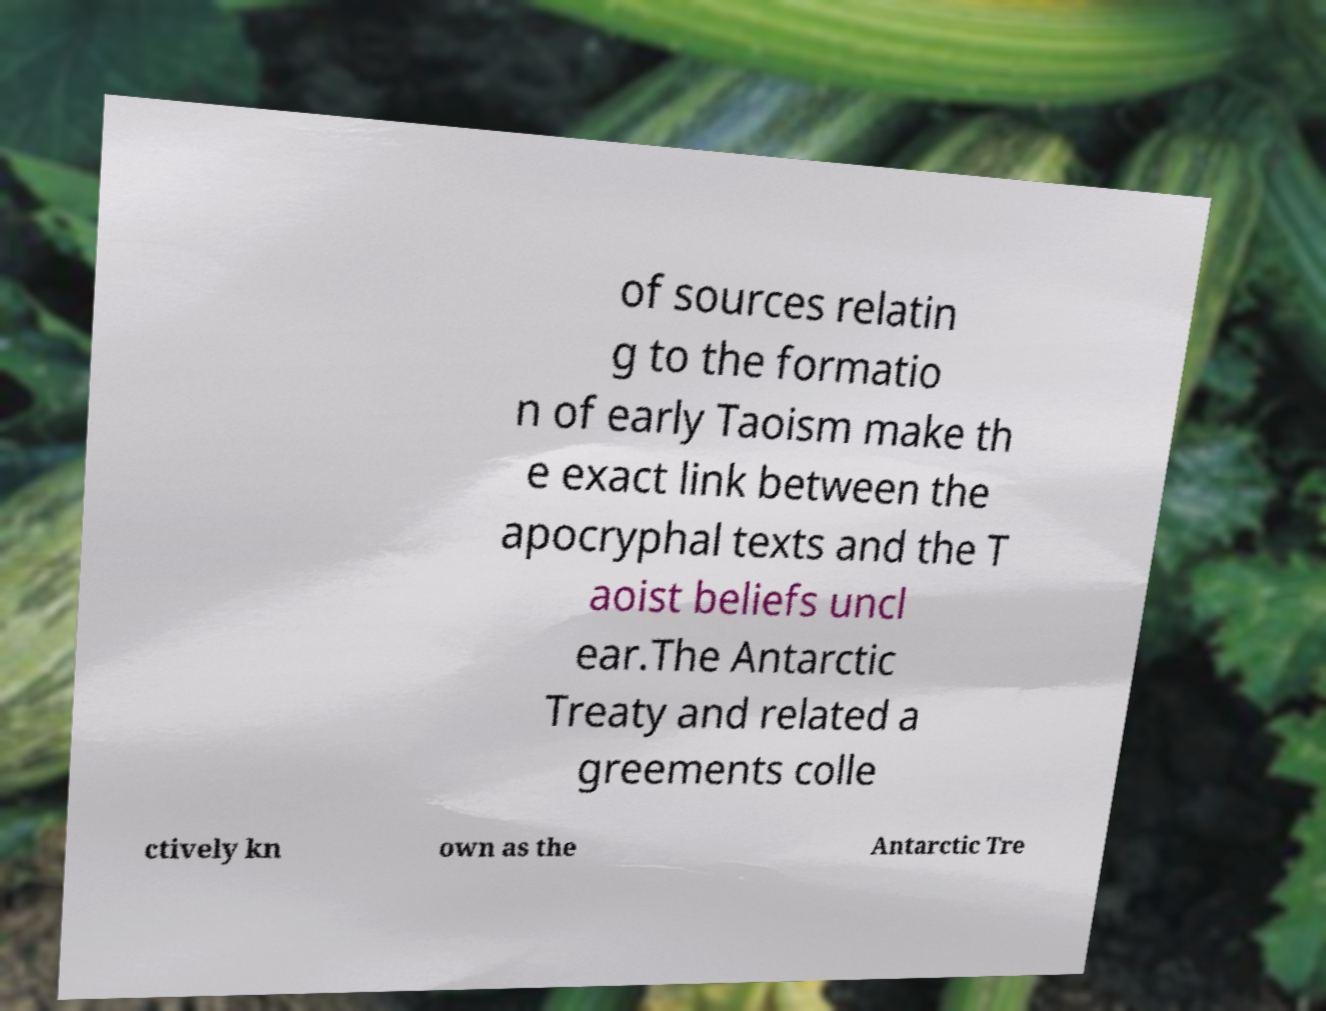Could you extract and type out the text from this image? of sources relatin g to the formatio n of early Taoism make th e exact link between the apocryphal texts and the T aoist beliefs uncl ear.The Antarctic Treaty and related a greements colle ctively kn own as the Antarctic Tre 